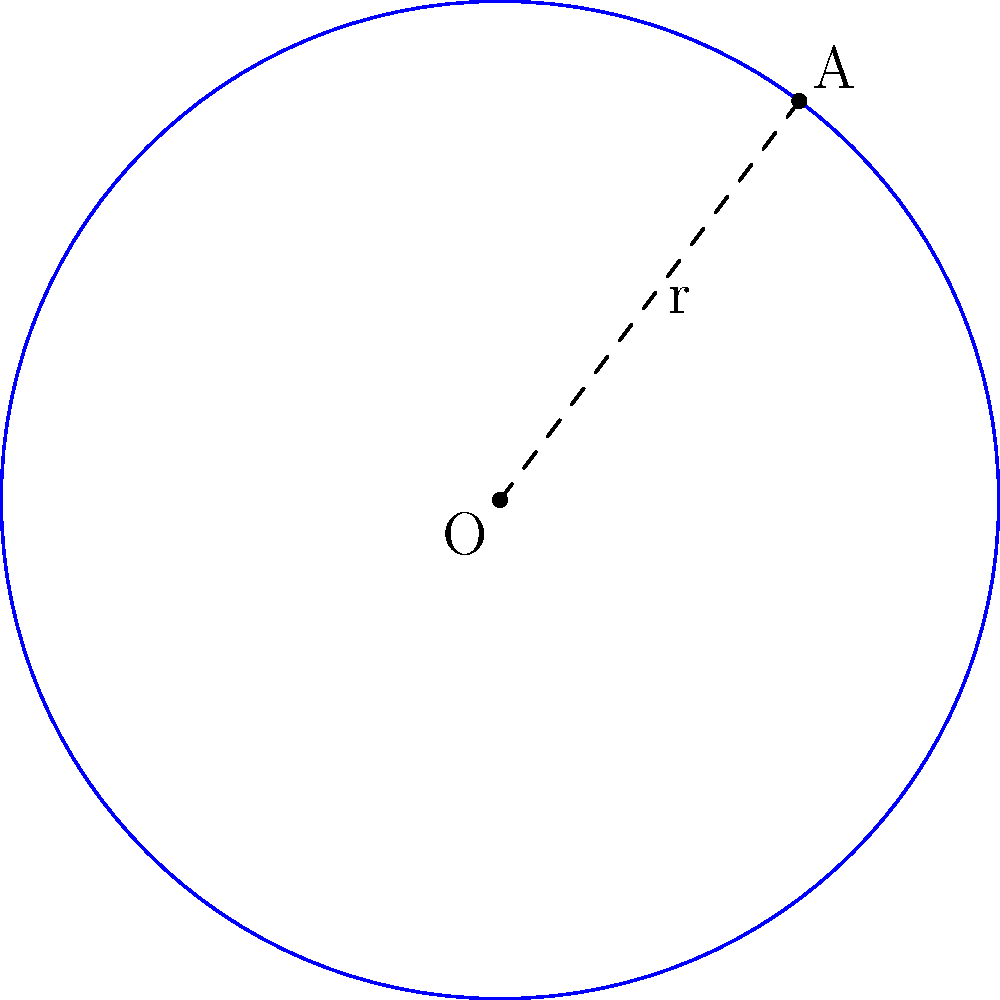In a study of a recent epidemic outbreak in Sri Lanka, the spread is modeled as a circular region. The center of the outbreak is represented by point O (0,0), and a confirmed case at the edge of the spread is located at point A (3,4). Calculate the area of the affected region. Round your answer to the nearest square kilometer. To find the area of the circular region representing the epidemic spread, we need to follow these steps:

1) First, we need to find the radius of the circle. We can do this by calculating the distance between points O and A using the distance formula:

   $r = \sqrt{(x_A - x_O)^2 + (y_A - y_O)^2}$
   $r = \sqrt{(3 - 0)^2 + (4 - 0)^2}$
   $r = \sqrt{9 + 16} = \sqrt{25} = 5$ km

2) Now that we have the radius, we can use the formula for the area of a circle:

   $A = \pi r^2$

3) Substituting our radius:

   $A = \pi (5)^2 = 25\pi$ sq km

4) Using $\pi \approx 3.14159$:

   $A \approx 25 * 3.14159 = 78.53975$ sq km

5) Rounding to the nearest square kilometer:

   $A \approx 79$ sq km

Therefore, the area of the affected region is approximately 79 square kilometers.
Answer: 79 sq km 